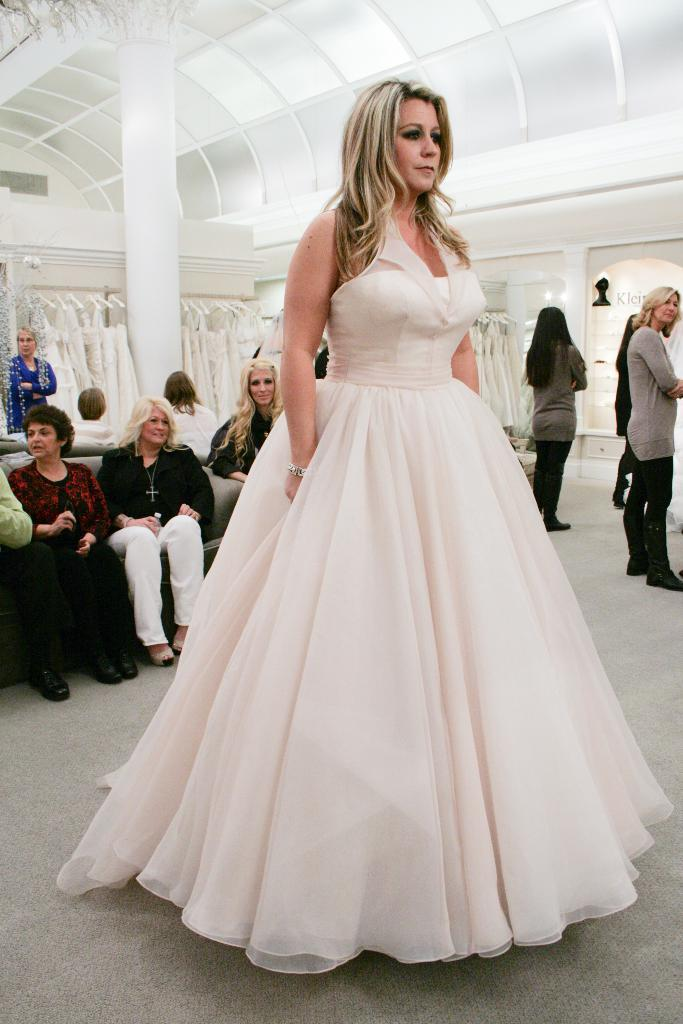How many people are in the image? There are people in the image, but the exact number is not specified. What are some of the people in the image doing? Some people are sitting in the image. Can you describe the appearance of the woman in the image? A woman is standing with a white dress in the image. What can be seen in the background of the image? There are clothes hanging on a wall in the background. Can you see a goose flying in the image? No, there is no goose or any indication of a flying object in the image. 